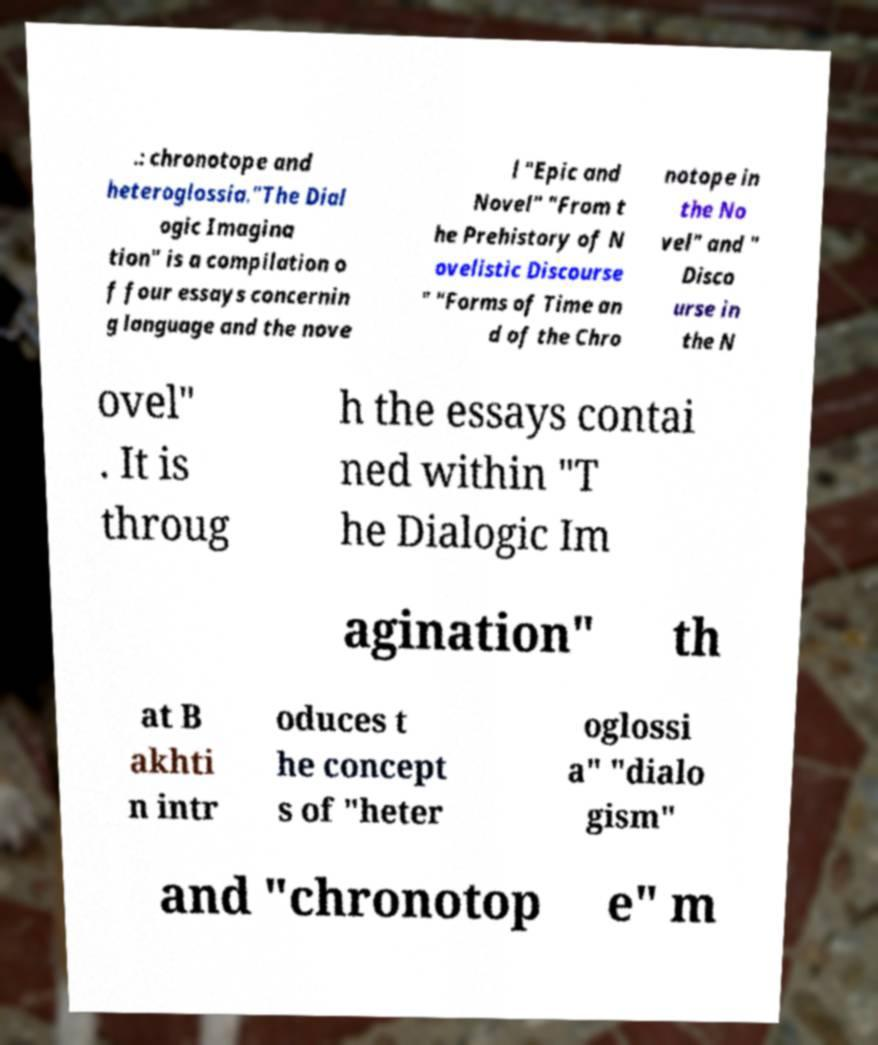Could you extract and type out the text from this image? .: chronotope and heteroglossia."The Dial ogic Imagina tion" is a compilation o f four essays concernin g language and the nove l "Epic and Novel" "From t he Prehistory of N ovelistic Discourse " "Forms of Time an d of the Chro notope in the No vel" and " Disco urse in the N ovel" . It is throug h the essays contai ned within "T he Dialogic Im agination" th at B akhti n intr oduces t he concept s of "heter oglossi a" "dialo gism" and "chronotop e" m 